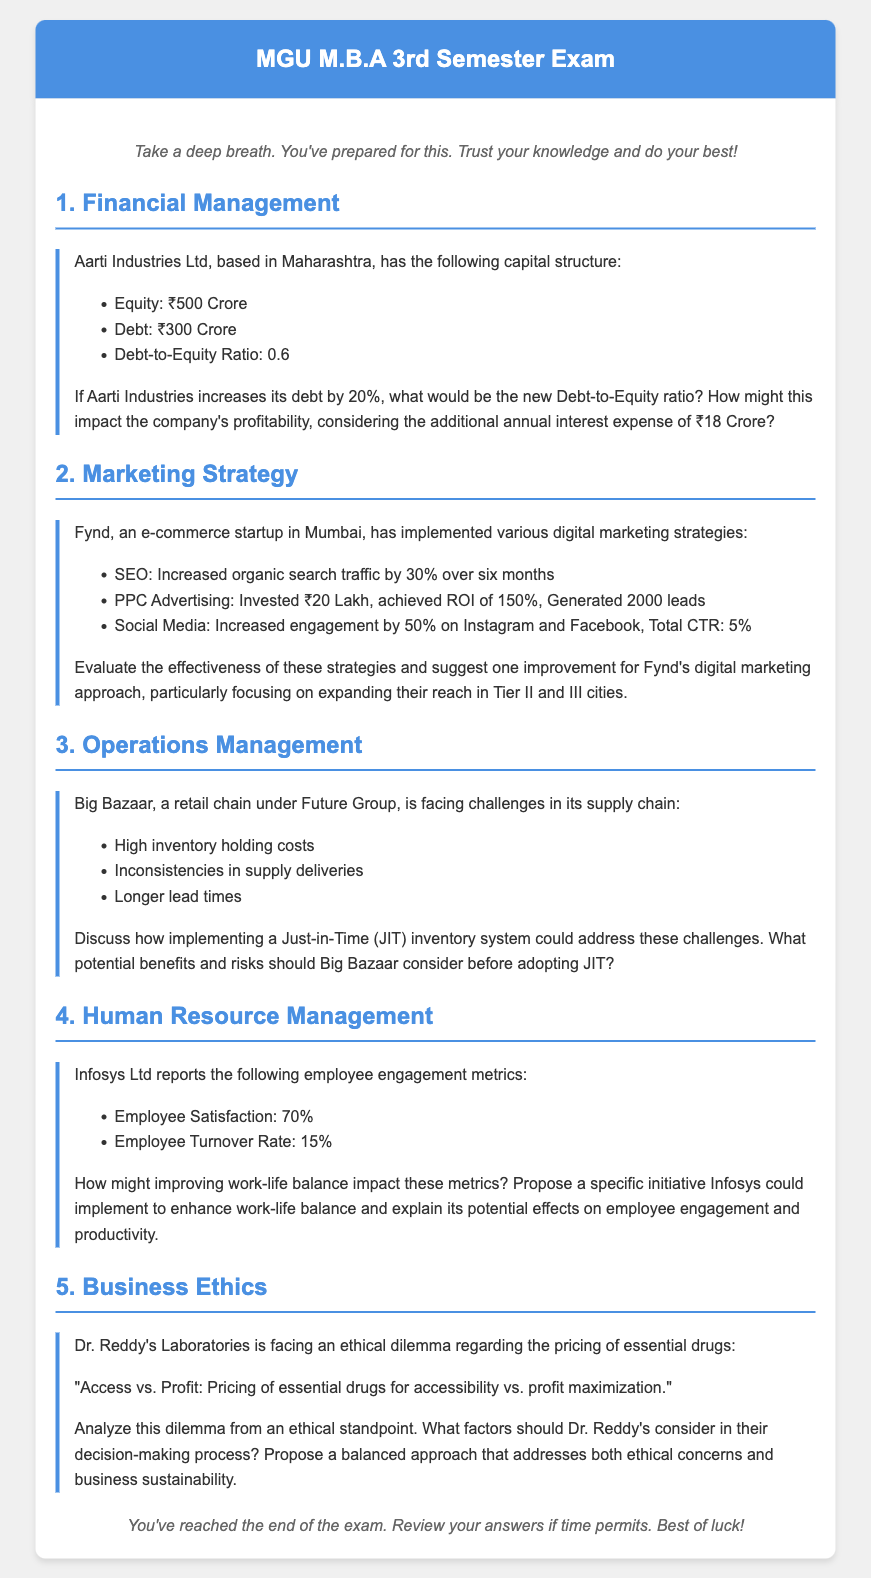What is Aarti Industries' current Debt-to-Equity Ratio? The Debt-to-Equity Ratio is provided in the document as 0.6.
Answer: 0.6 What is the annual interest expense after the increase in debt for Aarti Industries? The additional annual interest expense after increasing debt is specifically mentioned as ₹18 Crore.
Answer: ₹18 Crore What percentage increase in organic search traffic did Fynd achieve through SEO? The document states that Fynd's SEO efforts resulted in a 30% increase in organic search traffic over six months.
Answer: 30% What is the return on investment (ROI) achieved by Fynd from PPC advertising? Fynd achieved an ROI of 150% from its PPC advertising investments.
Answer: 150% What is the employee turnover rate reported by Infosys Ltd? The employee turnover rate is mentioned in the document as 15%.
Answer: 15% What inventory system is proposed for Big Bazaar to address supply chain challenges? The proposed inventory system mentioned for Big Bazaar is the Just-in-Time (JIT) inventory system.
Answer: Just-in-Time (JIT) What ethical dilemma is Dr. Reddy's Laboratories facing regarding essential drugs? The ethical dilemma is framed as "Access vs. Profit: Pricing of essential drugs for accessibility vs. profit maximization."
Answer: Access vs. Profit What is the employee satisfaction percentage reported by Infosys Ltd? The employee satisfaction percentage provided in the document is 70%.
Answer: 70% What social media engagement increase did Fynd experience? The document mentions that Fynd increased its engagement by 50% on Instagram and Facebook.
Answer: 50% 